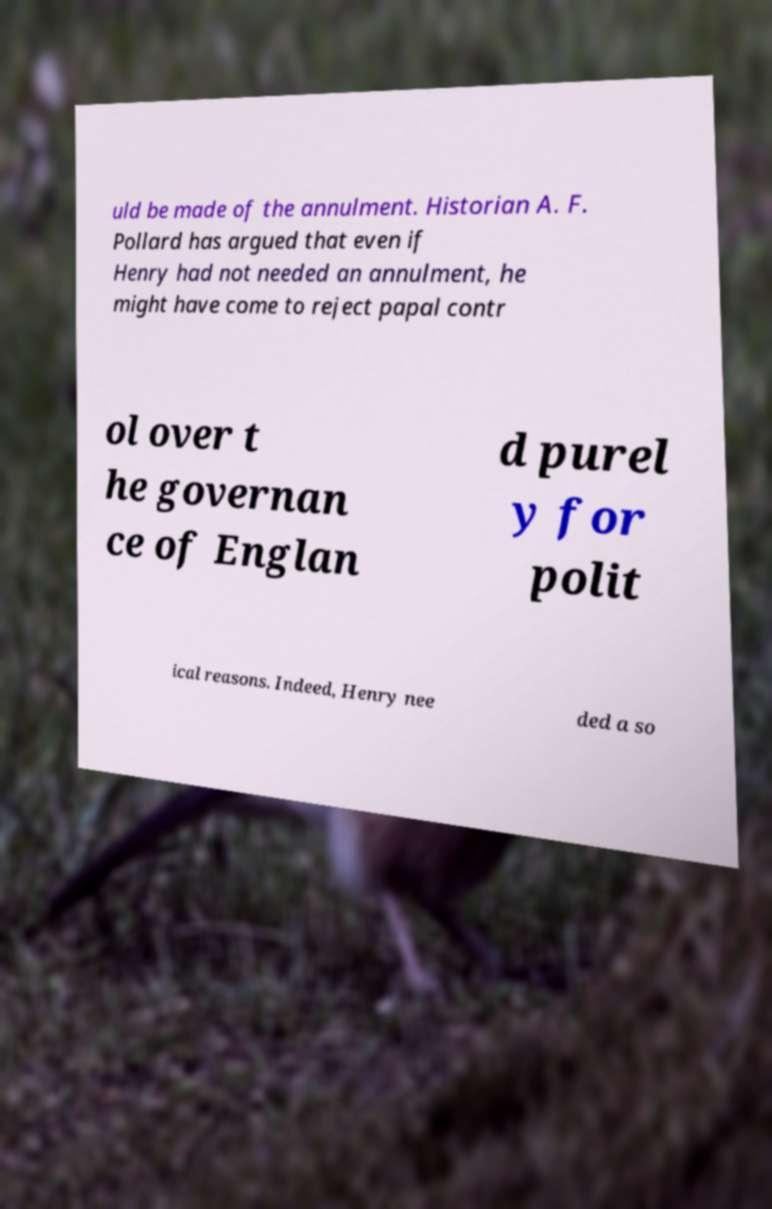I need the written content from this picture converted into text. Can you do that? uld be made of the annulment. Historian A. F. Pollard has argued that even if Henry had not needed an annulment, he might have come to reject papal contr ol over t he governan ce of Englan d purel y for polit ical reasons. Indeed, Henry nee ded a so 